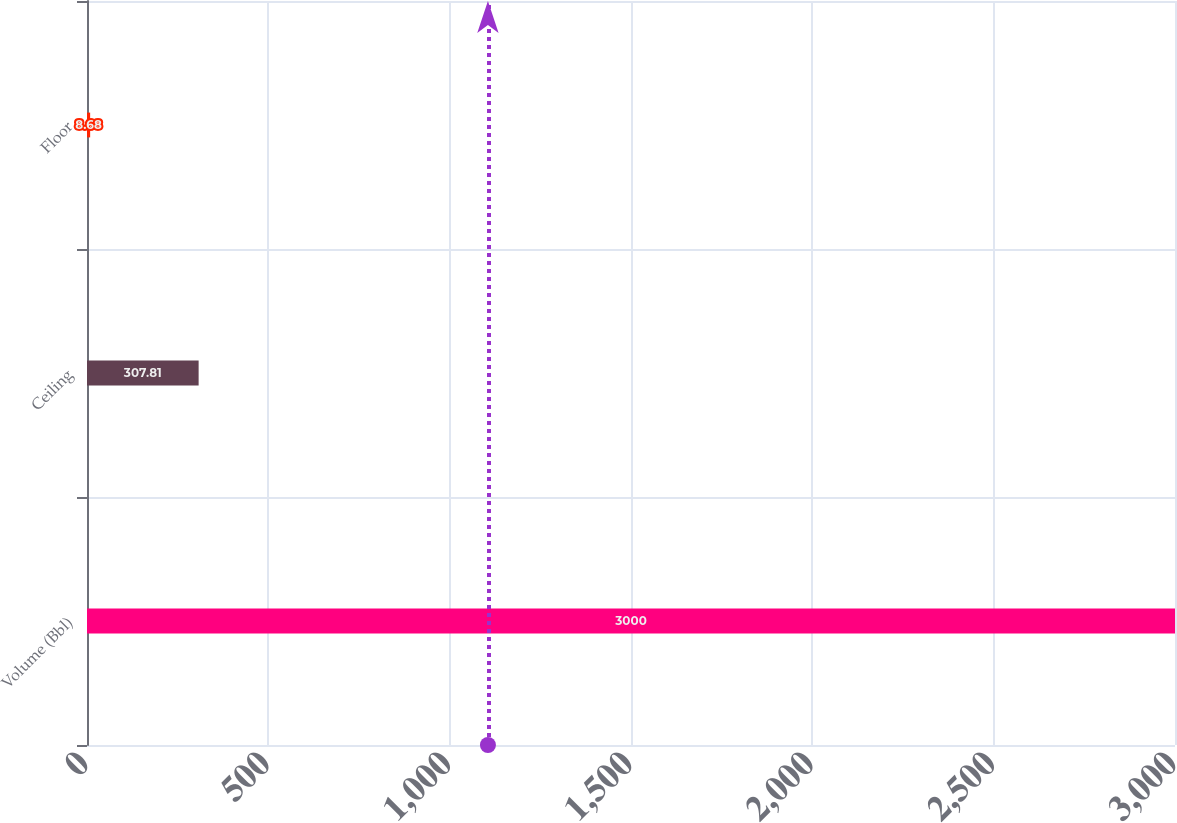Convert chart to OTSL. <chart><loc_0><loc_0><loc_500><loc_500><bar_chart><fcel>Volume (Bbl)<fcel>Ceiling<fcel>Floor<nl><fcel>3000<fcel>307.81<fcel>8.68<nl></chart> 